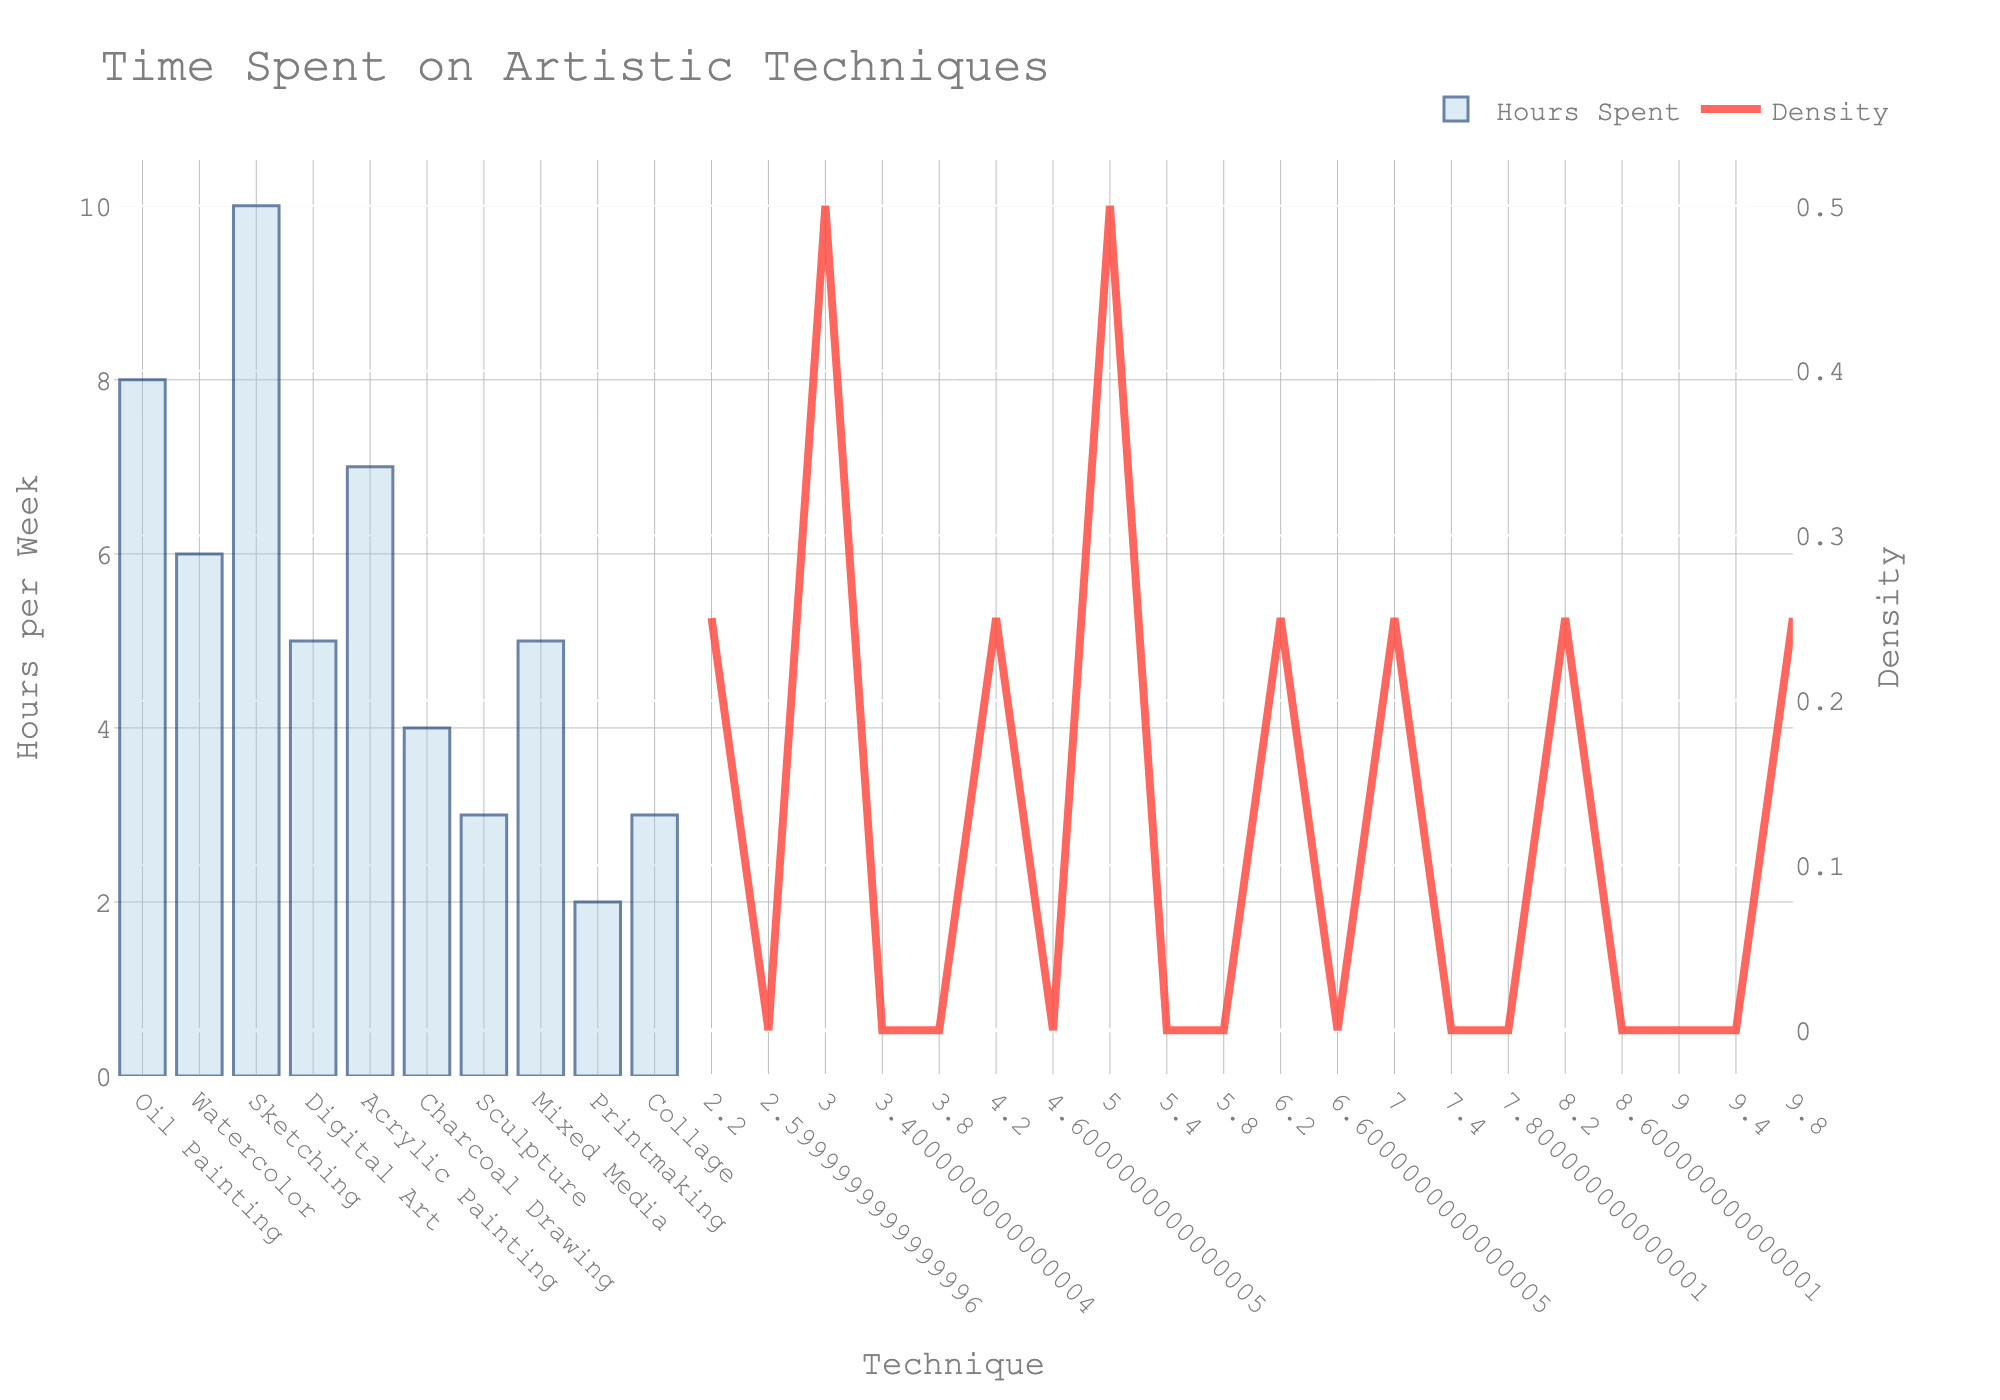What's the title of the figure? The title of a figure is usually found at the top and is meant to describe the main subject of the visualization. In this case, it reads "Time Spent on Artistic Techniques."
Answer: Time Spent on Artistic Techniques What artistic technique had the highest number of hours spent? To find which technique had the highest number of hours, look at the highest bar in the histogram. The tallest bar indicates the technique with the maximum hours. Here, Sketching has the tallest bar.
Answer: Sketching Which has fewer hours spent: Charcoal Drawing or Printmaking? Compare the heights of the bars labeled Charcoal Drawing and Printmaking. The bar for Printmaking is shorter than the bar for Charcoal Drawing.
Answer: Printmaking What's the average time spent on the six most time-consuming techniques? Identify the six highest bars and their corresponding hours: Sketching (10), Oil Painting (8), Acrylic Painting (7), Watercolor (6), Mixed Media (5), and Digital Art (5). Sum these values: 10 + 8 + 7 + 6 + 5 + 5 = 41. Then divide by 6 to find the average: 41 / 6 ≈ 6.83.
Answer: 6.83 Which technique had the least amount of time spent and by how much compared to the most time-consuming one? The bar that is the shortest shows the least time, which is Printmaking at 2 hours. The most time-consuming technique is Sketching at 10 hours. The difference is 10 - 2 = 8 hours.
Answer: Printmaking, by 8 hours What is the general trend shown by the KDE curve in relation to the histogram? The KDE curve shows the density of hours spent across different techniques. It generally follows the shape of the histogram, peaking around the highest frequencies and tapering off where fewer hours are spent. This indicates that most students spend between 4 to 10 hours on their artistic techniques.
Answer: Follows the histogram, peaks around 4-10 hours How many artistic techniques have 5 or more hours spent on them? Count the number of bars with heights representing 5 or more hours. The techniques are Oil Painting (8), Watercolor (6), Sketching (10), Acrylic Painting (7), Digital Art (5), and Mixed Media (5). There are six such techniques.
Answer: 6 What's the total amount of time spent across all the techniques? To find this, sum the hours for each technique: 10 + 8 + 7 + 6 + 5 + 5 + 4 + 3 + 3 + 2 = 53 hours.
Answer: 53 hours Which technique between Digital Art and Sculpture has more hours spent on it? Compare the heights of the bars for Digital Art and Sculpture. Digital Art's bar is taller with 5 hours compared to Sculpture's 3 hours.
Answer: Digital Art 